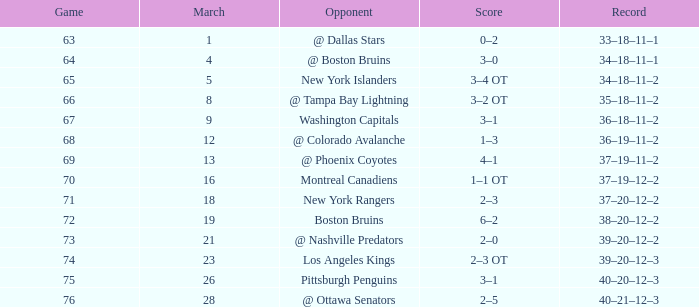Which Game is the highest one that has Points smaller than 92, and a Score of 1–3? 68.0. 